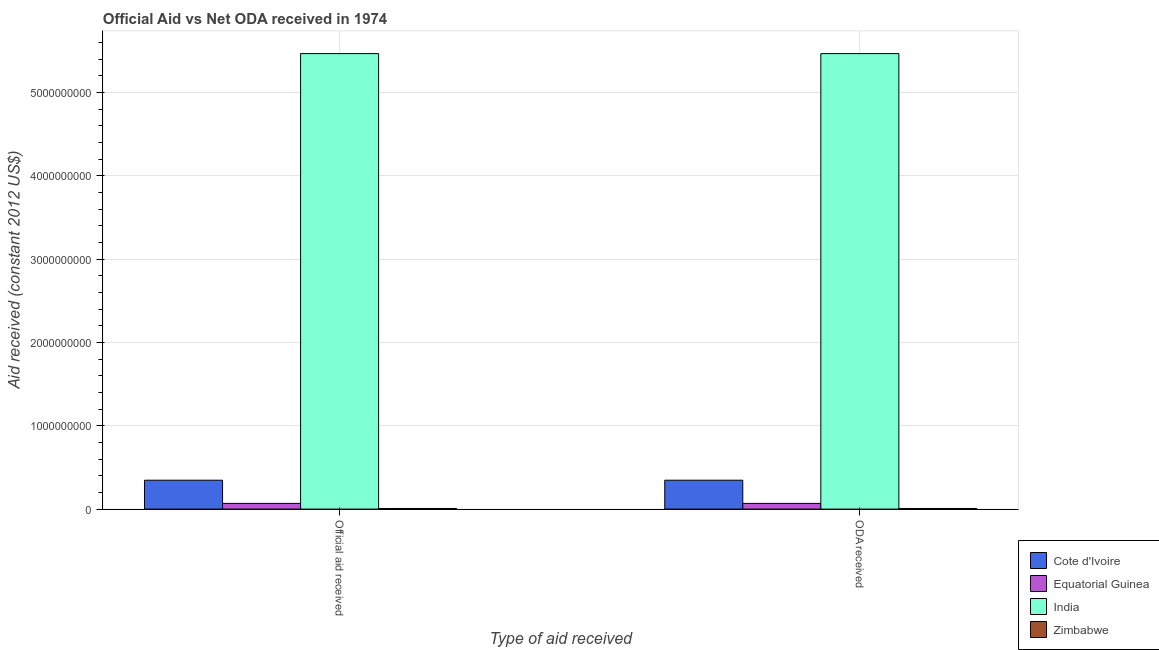How many different coloured bars are there?
Your answer should be very brief. 4. How many groups of bars are there?
Your answer should be very brief. 2. Are the number of bars on each tick of the X-axis equal?
Offer a very short reply. Yes. What is the label of the 1st group of bars from the left?
Offer a terse response. Official aid received. What is the oda received in India?
Your response must be concise. 5.47e+09. Across all countries, what is the maximum oda received?
Offer a terse response. 5.47e+09. Across all countries, what is the minimum official aid received?
Provide a succinct answer. 7.43e+06. In which country was the oda received minimum?
Keep it short and to the point. Zimbabwe. What is the total oda received in the graph?
Provide a short and direct response. 5.89e+09. What is the difference between the oda received in Cote d'Ivoire and that in Equatorial Guinea?
Offer a very short reply. 2.78e+08. What is the difference between the oda received in India and the official aid received in Zimbabwe?
Provide a succinct answer. 5.46e+09. What is the average oda received per country?
Ensure brevity in your answer.  1.47e+09. What is the difference between the oda received and official aid received in Equatorial Guinea?
Provide a succinct answer. 0. In how many countries, is the official aid received greater than 2400000000 US$?
Your answer should be compact. 1. What is the ratio of the official aid received in India to that in Equatorial Guinea?
Provide a short and direct response. 79.82. In how many countries, is the official aid received greater than the average official aid received taken over all countries?
Offer a terse response. 1. What does the 1st bar from the left in Official aid received represents?
Keep it short and to the point. Cote d'Ivoire. What does the 4th bar from the right in ODA received represents?
Offer a terse response. Cote d'Ivoire. Are all the bars in the graph horizontal?
Keep it short and to the point. No. How many countries are there in the graph?
Give a very brief answer. 4. Are the values on the major ticks of Y-axis written in scientific E-notation?
Keep it short and to the point. No. Does the graph contain any zero values?
Offer a very short reply. No. Does the graph contain grids?
Your answer should be compact. Yes. Where does the legend appear in the graph?
Ensure brevity in your answer.  Bottom right. How are the legend labels stacked?
Your answer should be very brief. Vertical. What is the title of the graph?
Offer a very short reply. Official Aid vs Net ODA received in 1974 . What is the label or title of the X-axis?
Provide a short and direct response. Type of aid received. What is the label or title of the Y-axis?
Keep it short and to the point. Aid received (constant 2012 US$). What is the Aid received (constant 2012 US$) in Cote d'Ivoire in Official aid received?
Offer a very short reply. 3.47e+08. What is the Aid received (constant 2012 US$) of Equatorial Guinea in Official aid received?
Ensure brevity in your answer.  6.85e+07. What is the Aid received (constant 2012 US$) in India in Official aid received?
Make the answer very short. 5.47e+09. What is the Aid received (constant 2012 US$) in Zimbabwe in Official aid received?
Ensure brevity in your answer.  7.43e+06. What is the Aid received (constant 2012 US$) of Cote d'Ivoire in ODA received?
Provide a succinct answer. 3.47e+08. What is the Aid received (constant 2012 US$) in Equatorial Guinea in ODA received?
Provide a short and direct response. 6.85e+07. What is the Aid received (constant 2012 US$) of India in ODA received?
Offer a very short reply. 5.47e+09. What is the Aid received (constant 2012 US$) of Zimbabwe in ODA received?
Make the answer very short. 7.43e+06. Across all Type of aid received, what is the maximum Aid received (constant 2012 US$) of Cote d'Ivoire?
Your answer should be very brief. 3.47e+08. Across all Type of aid received, what is the maximum Aid received (constant 2012 US$) of Equatorial Guinea?
Provide a succinct answer. 6.85e+07. Across all Type of aid received, what is the maximum Aid received (constant 2012 US$) in India?
Ensure brevity in your answer.  5.47e+09. Across all Type of aid received, what is the maximum Aid received (constant 2012 US$) of Zimbabwe?
Provide a short and direct response. 7.43e+06. Across all Type of aid received, what is the minimum Aid received (constant 2012 US$) of Cote d'Ivoire?
Offer a terse response. 3.47e+08. Across all Type of aid received, what is the minimum Aid received (constant 2012 US$) in Equatorial Guinea?
Offer a terse response. 6.85e+07. Across all Type of aid received, what is the minimum Aid received (constant 2012 US$) in India?
Provide a short and direct response. 5.47e+09. Across all Type of aid received, what is the minimum Aid received (constant 2012 US$) in Zimbabwe?
Your response must be concise. 7.43e+06. What is the total Aid received (constant 2012 US$) of Cote d'Ivoire in the graph?
Ensure brevity in your answer.  6.93e+08. What is the total Aid received (constant 2012 US$) of Equatorial Guinea in the graph?
Offer a terse response. 1.37e+08. What is the total Aid received (constant 2012 US$) in India in the graph?
Your answer should be compact. 1.09e+1. What is the total Aid received (constant 2012 US$) of Zimbabwe in the graph?
Keep it short and to the point. 1.49e+07. What is the difference between the Aid received (constant 2012 US$) of Zimbabwe in Official aid received and that in ODA received?
Make the answer very short. 0. What is the difference between the Aid received (constant 2012 US$) in Cote d'Ivoire in Official aid received and the Aid received (constant 2012 US$) in Equatorial Guinea in ODA received?
Your response must be concise. 2.78e+08. What is the difference between the Aid received (constant 2012 US$) of Cote d'Ivoire in Official aid received and the Aid received (constant 2012 US$) of India in ODA received?
Keep it short and to the point. -5.12e+09. What is the difference between the Aid received (constant 2012 US$) of Cote d'Ivoire in Official aid received and the Aid received (constant 2012 US$) of Zimbabwe in ODA received?
Provide a succinct answer. 3.39e+08. What is the difference between the Aid received (constant 2012 US$) in Equatorial Guinea in Official aid received and the Aid received (constant 2012 US$) in India in ODA received?
Your answer should be very brief. -5.40e+09. What is the difference between the Aid received (constant 2012 US$) in Equatorial Guinea in Official aid received and the Aid received (constant 2012 US$) in Zimbabwe in ODA received?
Your response must be concise. 6.10e+07. What is the difference between the Aid received (constant 2012 US$) of India in Official aid received and the Aid received (constant 2012 US$) of Zimbabwe in ODA received?
Offer a terse response. 5.46e+09. What is the average Aid received (constant 2012 US$) in Cote d'Ivoire per Type of aid received?
Give a very brief answer. 3.47e+08. What is the average Aid received (constant 2012 US$) of Equatorial Guinea per Type of aid received?
Your answer should be compact. 6.85e+07. What is the average Aid received (constant 2012 US$) in India per Type of aid received?
Your response must be concise. 5.47e+09. What is the average Aid received (constant 2012 US$) of Zimbabwe per Type of aid received?
Your answer should be compact. 7.43e+06. What is the difference between the Aid received (constant 2012 US$) of Cote d'Ivoire and Aid received (constant 2012 US$) of Equatorial Guinea in Official aid received?
Ensure brevity in your answer.  2.78e+08. What is the difference between the Aid received (constant 2012 US$) of Cote d'Ivoire and Aid received (constant 2012 US$) of India in Official aid received?
Give a very brief answer. -5.12e+09. What is the difference between the Aid received (constant 2012 US$) in Cote d'Ivoire and Aid received (constant 2012 US$) in Zimbabwe in Official aid received?
Your answer should be compact. 3.39e+08. What is the difference between the Aid received (constant 2012 US$) in Equatorial Guinea and Aid received (constant 2012 US$) in India in Official aid received?
Your response must be concise. -5.40e+09. What is the difference between the Aid received (constant 2012 US$) of Equatorial Guinea and Aid received (constant 2012 US$) of Zimbabwe in Official aid received?
Ensure brevity in your answer.  6.10e+07. What is the difference between the Aid received (constant 2012 US$) of India and Aid received (constant 2012 US$) of Zimbabwe in Official aid received?
Your answer should be compact. 5.46e+09. What is the difference between the Aid received (constant 2012 US$) in Cote d'Ivoire and Aid received (constant 2012 US$) in Equatorial Guinea in ODA received?
Ensure brevity in your answer.  2.78e+08. What is the difference between the Aid received (constant 2012 US$) in Cote d'Ivoire and Aid received (constant 2012 US$) in India in ODA received?
Offer a very short reply. -5.12e+09. What is the difference between the Aid received (constant 2012 US$) of Cote d'Ivoire and Aid received (constant 2012 US$) of Zimbabwe in ODA received?
Your answer should be very brief. 3.39e+08. What is the difference between the Aid received (constant 2012 US$) in Equatorial Guinea and Aid received (constant 2012 US$) in India in ODA received?
Your answer should be very brief. -5.40e+09. What is the difference between the Aid received (constant 2012 US$) in Equatorial Guinea and Aid received (constant 2012 US$) in Zimbabwe in ODA received?
Offer a terse response. 6.10e+07. What is the difference between the Aid received (constant 2012 US$) in India and Aid received (constant 2012 US$) in Zimbabwe in ODA received?
Provide a succinct answer. 5.46e+09. What is the ratio of the Aid received (constant 2012 US$) of Cote d'Ivoire in Official aid received to that in ODA received?
Provide a short and direct response. 1. What is the difference between the highest and the second highest Aid received (constant 2012 US$) in Equatorial Guinea?
Ensure brevity in your answer.  0. What is the difference between the highest and the second highest Aid received (constant 2012 US$) of India?
Give a very brief answer. 0. What is the difference between the highest and the lowest Aid received (constant 2012 US$) of Equatorial Guinea?
Give a very brief answer. 0. What is the difference between the highest and the lowest Aid received (constant 2012 US$) of India?
Keep it short and to the point. 0. 